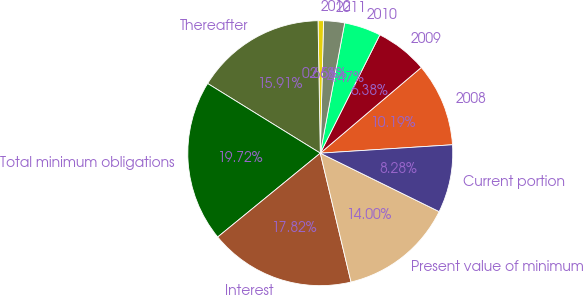<chart> <loc_0><loc_0><loc_500><loc_500><pie_chart><fcel>2008<fcel>2009<fcel>2010<fcel>2011<fcel>2012<fcel>Thereafter<fcel>Total minimum obligations<fcel>Interest<fcel>Present value of minimum<fcel>Current portion<nl><fcel>10.19%<fcel>6.38%<fcel>4.47%<fcel>2.56%<fcel>0.66%<fcel>15.91%<fcel>19.72%<fcel>17.82%<fcel>14.0%<fcel>8.28%<nl></chart> 